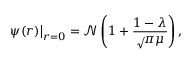Convert formula to latex. <formula><loc_0><loc_0><loc_500><loc_500>\psi ( r ) \right | _ { r = 0 } = \mathcal { N } \left ( 1 + \frac { 1 - \lambda } { \sqrt { \pi } \mu } \right ) ,</formula> 